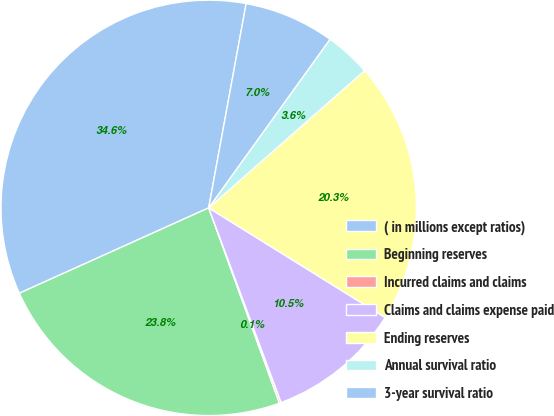Convert chart to OTSL. <chart><loc_0><loc_0><loc_500><loc_500><pie_chart><fcel>( in millions except ratios)<fcel>Beginning reserves<fcel>Incurred claims and claims<fcel>Claims and claims expense paid<fcel>Ending reserves<fcel>Annual survival ratio<fcel>3-year survival ratio<nl><fcel>34.63%<fcel>23.79%<fcel>0.14%<fcel>10.48%<fcel>20.34%<fcel>3.59%<fcel>7.04%<nl></chart> 